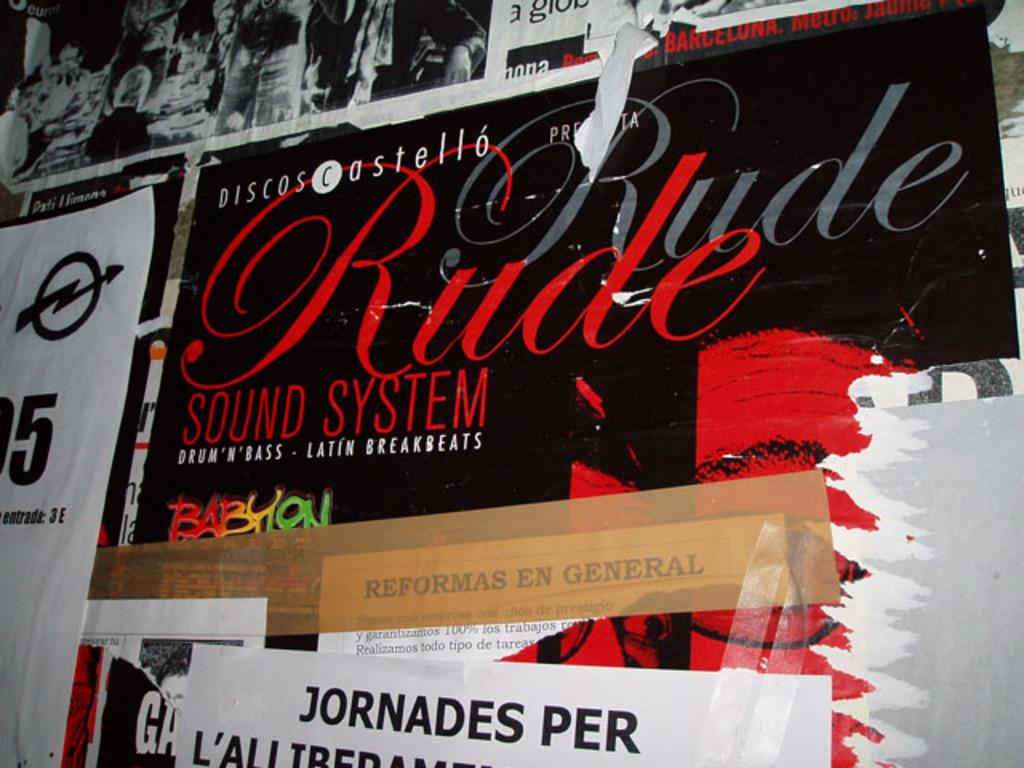Provide a one-sentence caption for the provided image. A cardboard box from a Rude Sound System. 